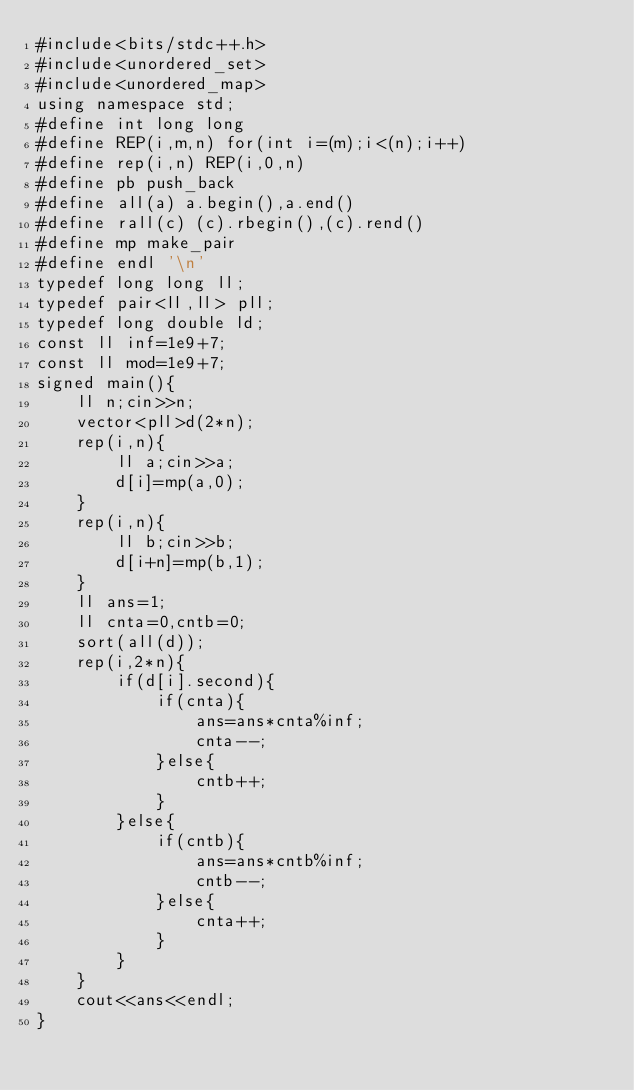Convert code to text. <code><loc_0><loc_0><loc_500><loc_500><_C++_>#include<bits/stdc++.h>
#include<unordered_set>
#include<unordered_map>
using namespace std;
#define int long long
#define REP(i,m,n) for(int i=(m);i<(n);i++)
#define rep(i,n) REP(i,0,n)
#define pb push_back
#define all(a) a.begin(),a.end()
#define rall(c) (c).rbegin(),(c).rend()
#define mp make_pair
#define endl '\n'
typedef long long ll;
typedef pair<ll,ll> pll;
typedef long double ld;
const ll inf=1e9+7;
const ll mod=1e9+7;
signed main(){
    ll n;cin>>n;
    vector<pll>d(2*n);
    rep(i,n){
        ll a;cin>>a;
        d[i]=mp(a,0);
    }
    rep(i,n){
        ll b;cin>>b;
        d[i+n]=mp(b,1);
    }
    ll ans=1;
    ll cnta=0,cntb=0;
    sort(all(d));
    rep(i,2*n){
        if(d[i].second){
            if(cnta){
                ans=ans*cnta%inf;
                cnta--;
            }else{
                cntb++;
            }
        }else{
            if(cntb){
                ans=ans*cntb%inf;
                cntb--;
            }else{
                cnta++;
            }
        }
    }
    cout<<ans<<endl;
}</code> 